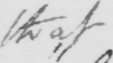Can you tell me what this handwritten text says? that 